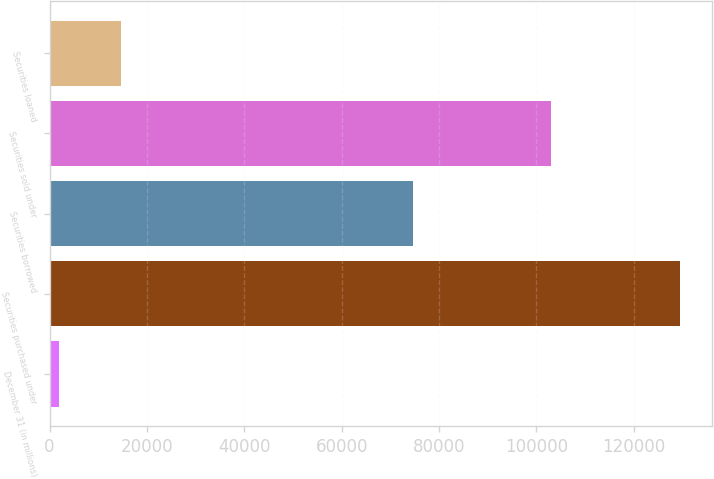Convert chart. <chart><loc_0><loc_0><loc_500><loc_500><bar_chart><fcel>December 31 (in millions)<fcel>Securities purchased under<fcel>Securities borrowed<fcel>Securities sold under<fcel>Securities loaned<nl><fcel>2005<fcel>129570<fcel>74604<fcel>103052<fcel>14761.5<nl></chart> 